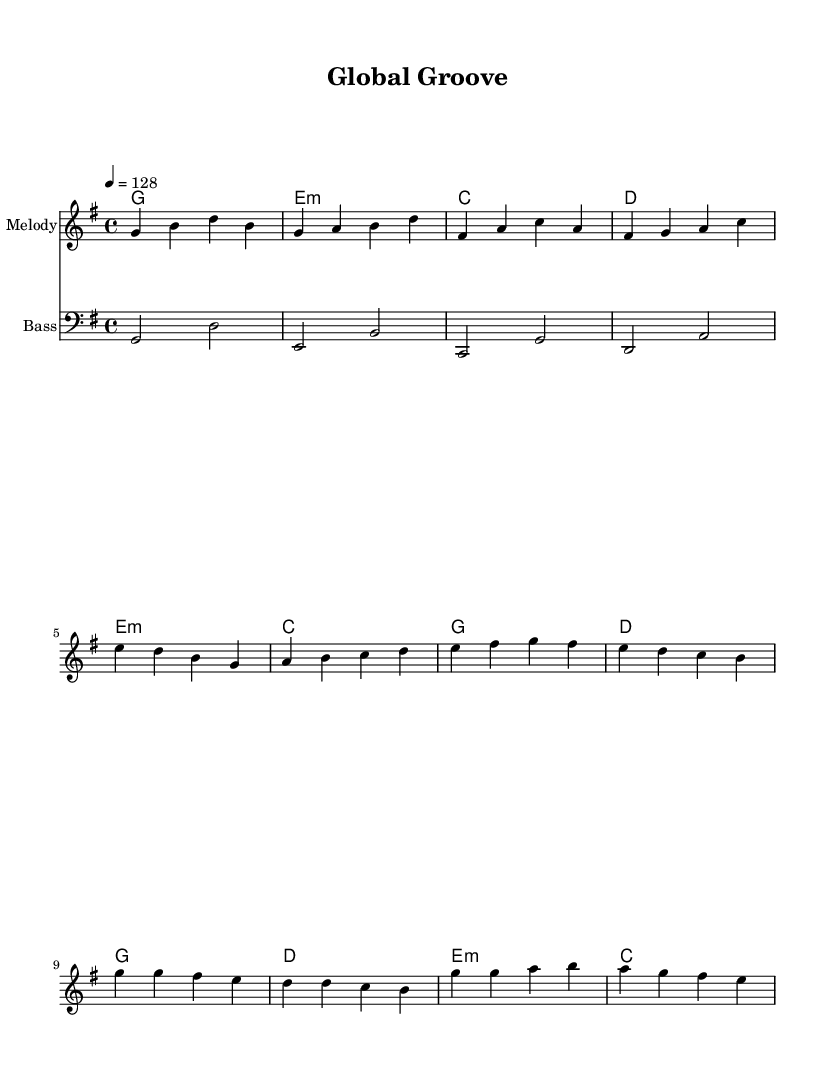What is the key signature of this music? The key signature is G major, which has one sharp (F#). The information is found at the beginning of the score where the key signature is notated.
Answer: G major What is the time signature of this music? The time signature is 4/4, indicating four beats in a measure and a quarter note receives one beat. This can be found at the beginning of the score next to the key signature.
Answer: 4/4 What is the tempo marking for this piece? The tempo marking is 128 beats per minute, which sets the pace for the piece. This is indicated in the score as "4 = 128".
Answer: 128 How many measures are in the verse section? The verse section consists of four measures, as counted in the melody part where the verse notes are located.
Answer: 4 Which chord is used in the pre-chorus section? The chords used in the pre-chorus are E minor, C major, G major, and D major, specifically labeled in the harmonies section.
Answer: E minor What is the rhythmic pattern of the bass line in the score? The bass line has a repeated rhythmic pattern with half notes, showing a continuity throughout the measures. By observing the bass section, you can see this repetitive structure.
Answer: Half notes What makes this piece a K-Pop dance hit? The composition features catchy melodic hooks, a danceable tempo, and a structure that emphasizes strong choruses typical of K-Pop style. This can be understood by analyzing the song structure and rhythmic elements appropriate for dancing.
Answer: Catchy hooks 